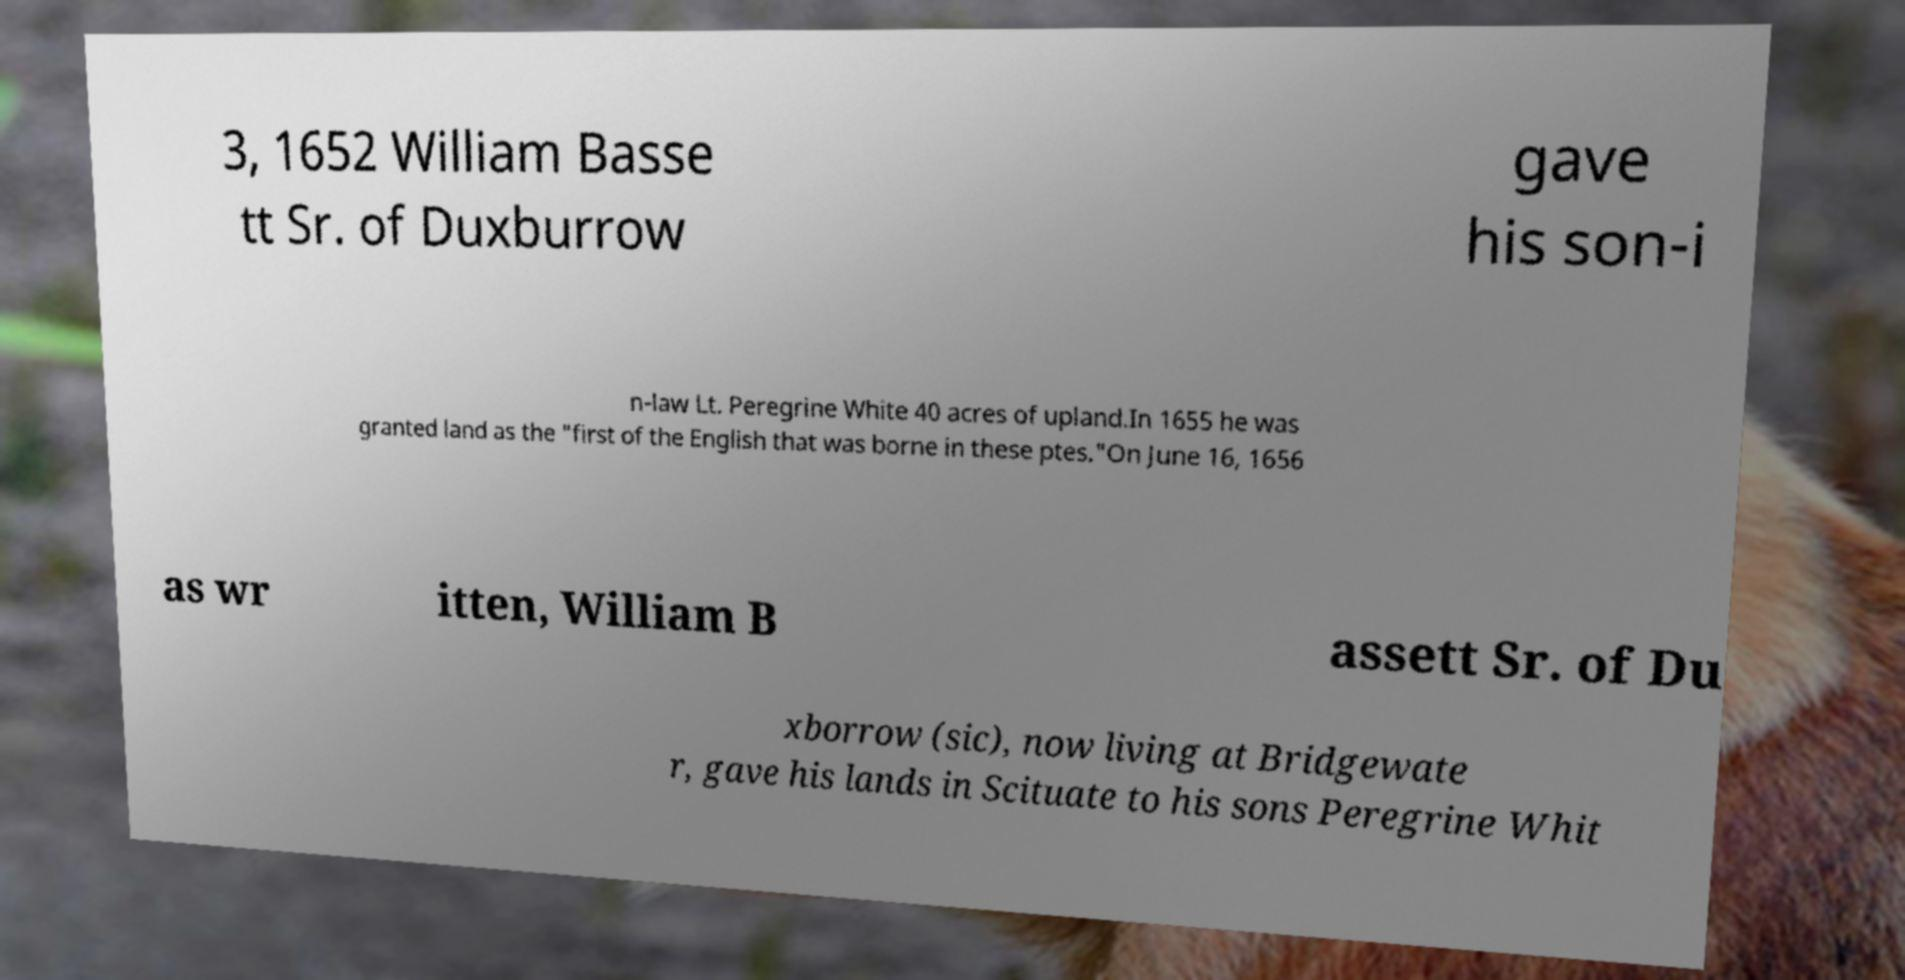Could you assist in decoding the text presented in this image and type it out clearly? 3, 1652 William Basse tt Sr. of Duxburrow gave his son-i n-law Lt. Peregrine White 40 acres of upland.In 1655 he was granted land as the "first of the English that was borne in these ptes."On June 16, 1656 as wr itten, William B assett Sr. of Du xborrow (sic), now living at Bridgewate r, gave his lands in Scituate to his sons Peregrine Whit 